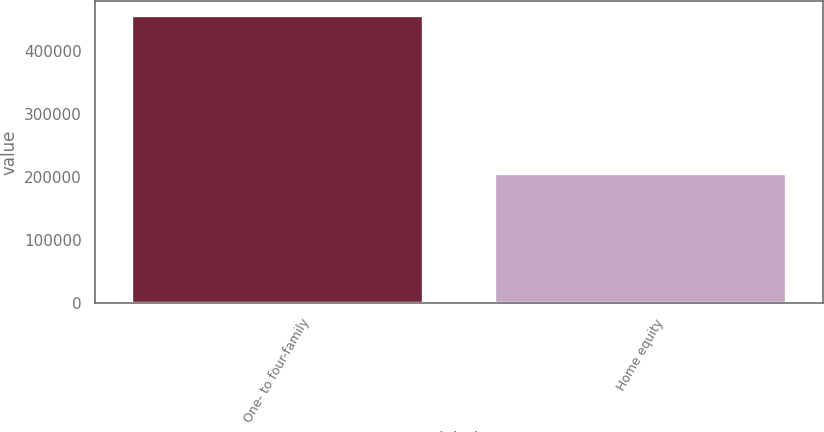<chart> <loc_0><loc_0><loc_500><loc_500><bar_chart><fcel>One- to four-family<fcel>Home equity<nl><fcel>456109<fcel>205879<nl></chart> 